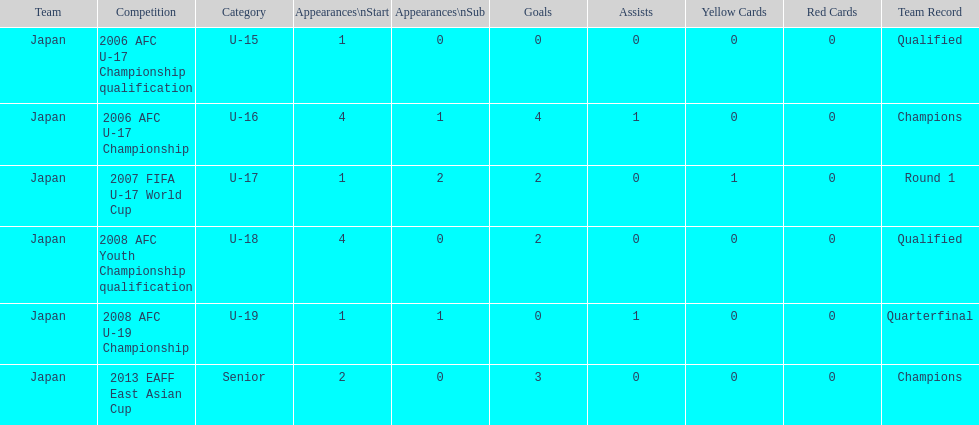Which was the earliest event to feature a substitute player? 2006 AFC U-17 Championship. 